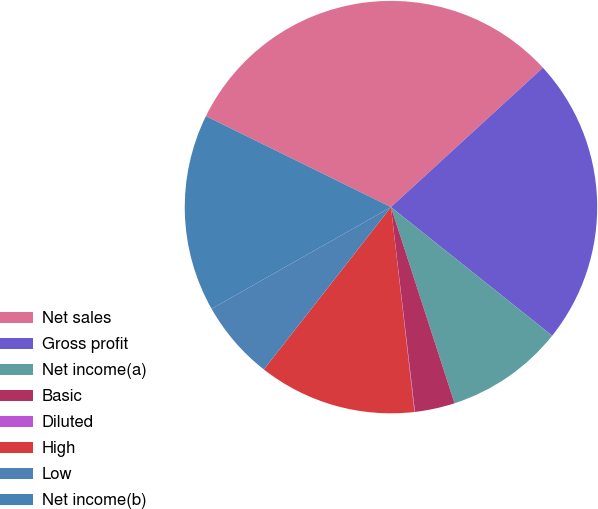Convert chart. <chart><loc_0><loc_0><loc_500><loc_500><pie_chart><fcel>Net sales<fcel>Gross profit<fcel>Net income(a)<fcel>Basic<fcel>Diluted<fcel>High<fcel>Low<fcel>Net income(b)<nl><fcel>30.92%<fcel>22.53%<fcel>9.3%<fcel>3.13%<fcel>0.04%<fcel>12.39%<fcel>6.22%<fcel>15.48%<nl></chart> 